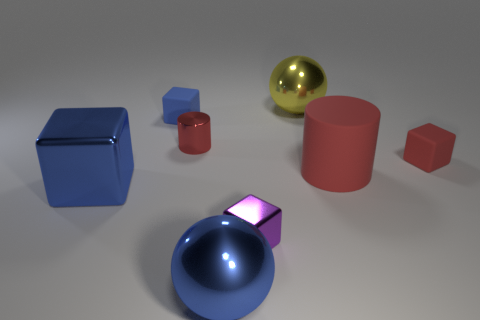Subtract all blue metallic blocks. How many blocks are left? 3 Subtract all cylinders. How many objects are left? 6 Subtract all cyan cubes. Subtract all cyan spheres. How many cubes are left? 4 Subtract all blue cylinders. How many red cubes are left? 1 Subtract all tiny blue objects. Subtract all tiny matte blocks. How many objects are left? 5 Add 6 tiny rubber objects. How many tiny rubber objects are left? 8 Add 2 tiny purple things. How many tiny purple things exist? 3 Add 2 big brown blocks. How many objects exist? 10 Subtract all purple cubes. How many cubes are left? 3 Subtract 0 yellow cylinders. How many objects are left? 8 